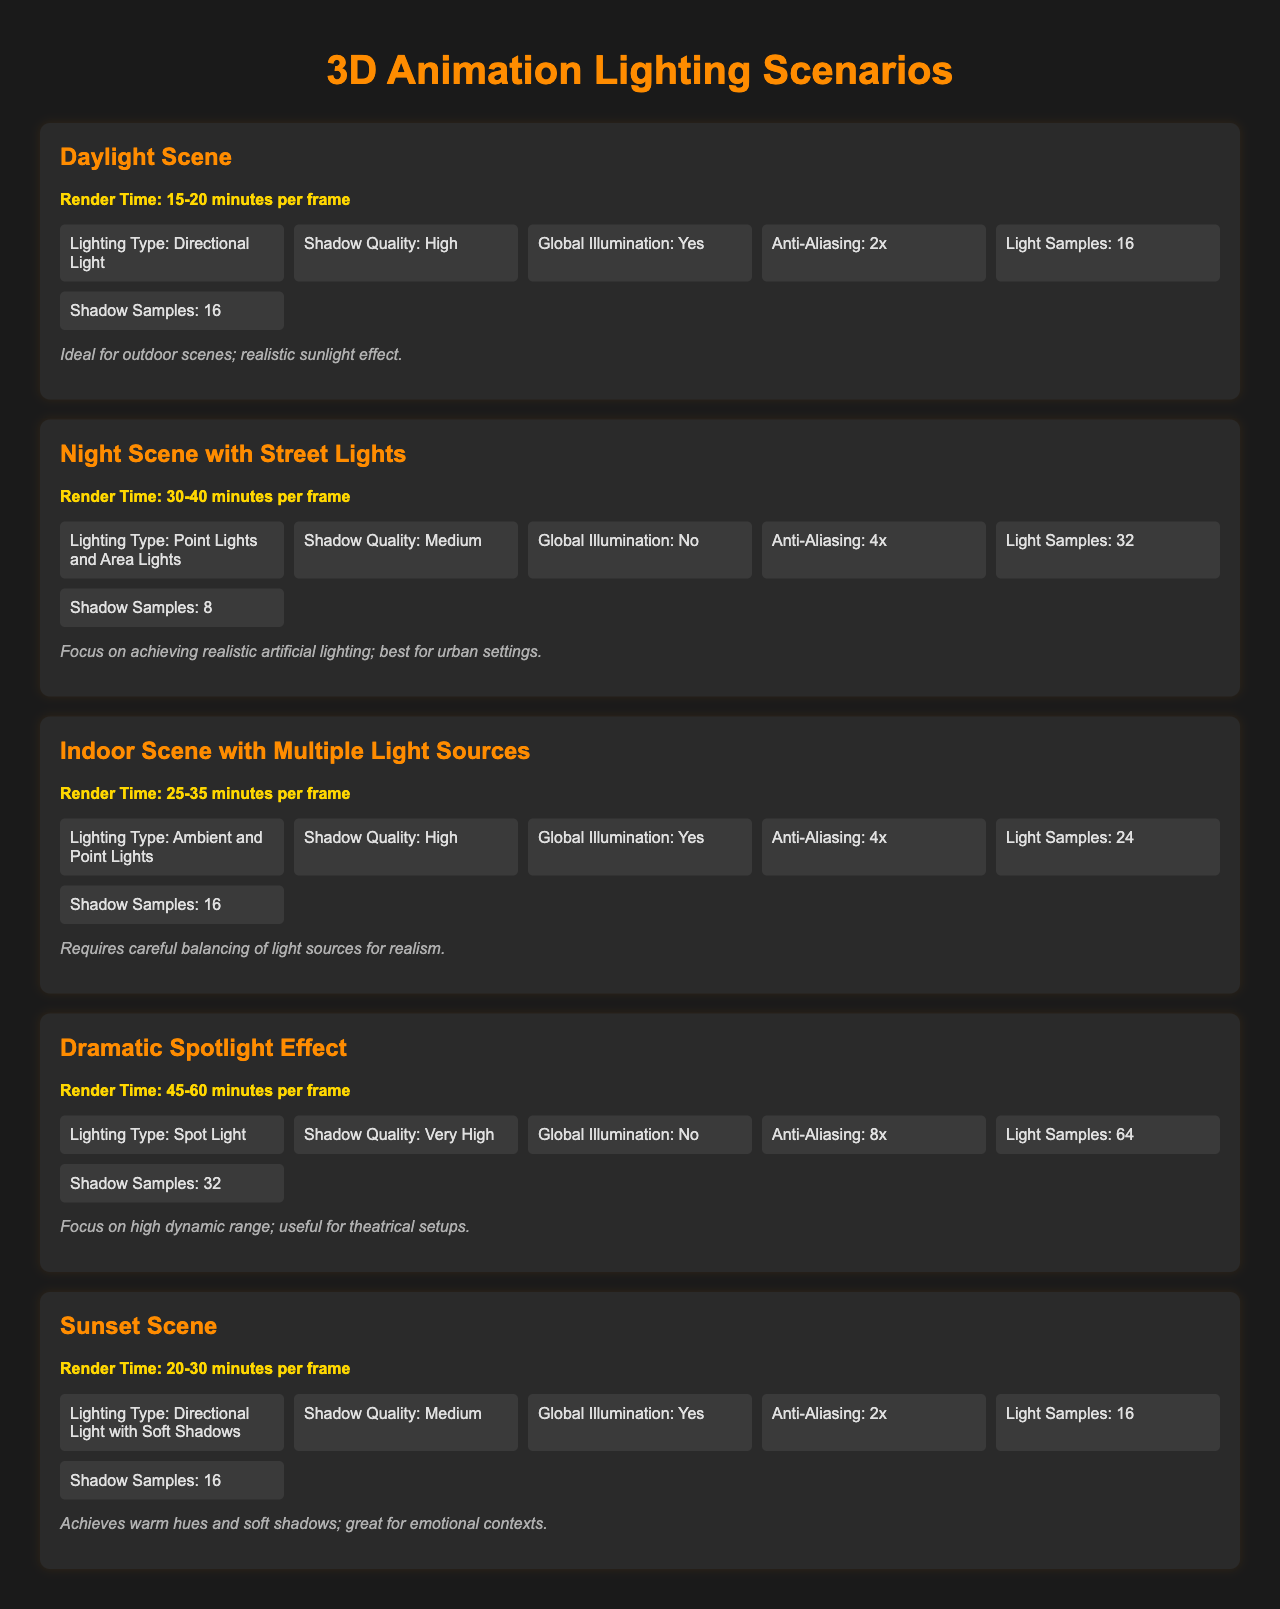What is the render time for the Daylight Scene? The render time is specified in the document as 15-20 minutes per frame for the Daylight Scene.
Answer: 15-20 minutes per frame Which lighting type is used in the Indoor Scene? The document mentions that the Indoor Scene uses Ambient and Point Lights as its lighting types.
Answer: Ambient and Point Lights What is the shadow quality setting for the Night Scene with Street Lights? According to the document, the shadow quality setting for the Night Scene with Street Lights is Medium.
Answer: Medium How many light samples are specified for the Dramatic Spotlight Effect? The document states that the Dramatic Spotlight Effect has 64 light samples.
Answer: 64 What scene is ideal for achieving warm hues and soft shadows? The document indicates that the Sunset Scene is ideal for achieving warm hues and soft shadows.
Answer: Sunset Scene What is the render time range for the Indoor Scene? The document provides the render time range for the Indoor Scene as 25-35 minutes per frame.
Answer: 25-35 minutes per frame Which setting is used for Anti-Aliasing in the Daylight Scene? The Daylight Scene has Anti-Aliasing set to 2x, as mentioned in the document.
Answer: 2x What did the remarks say about the Night Scene with Street Lights? The remarks for the Night Scene with Street Lights emphasize achieving realistic artificial lighting, suitable for urban settings.
Answer: Achieving realistic artificial lighting; best for urban settings 